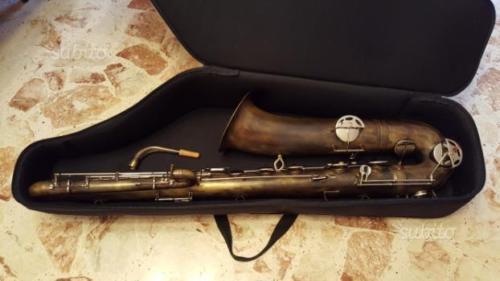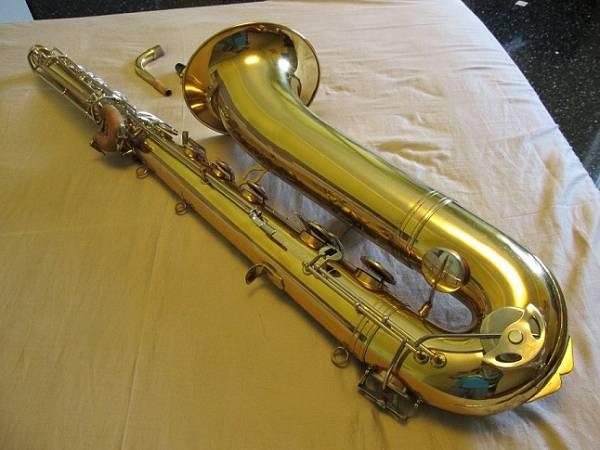The first image is the image on the left, the second image is the image on the right. Given the left and right images, does the statement "A saxophone with the mouth piece removed is laying on a wrinkled tan colored cloth." hold true? Answer yes or no. Yes. 